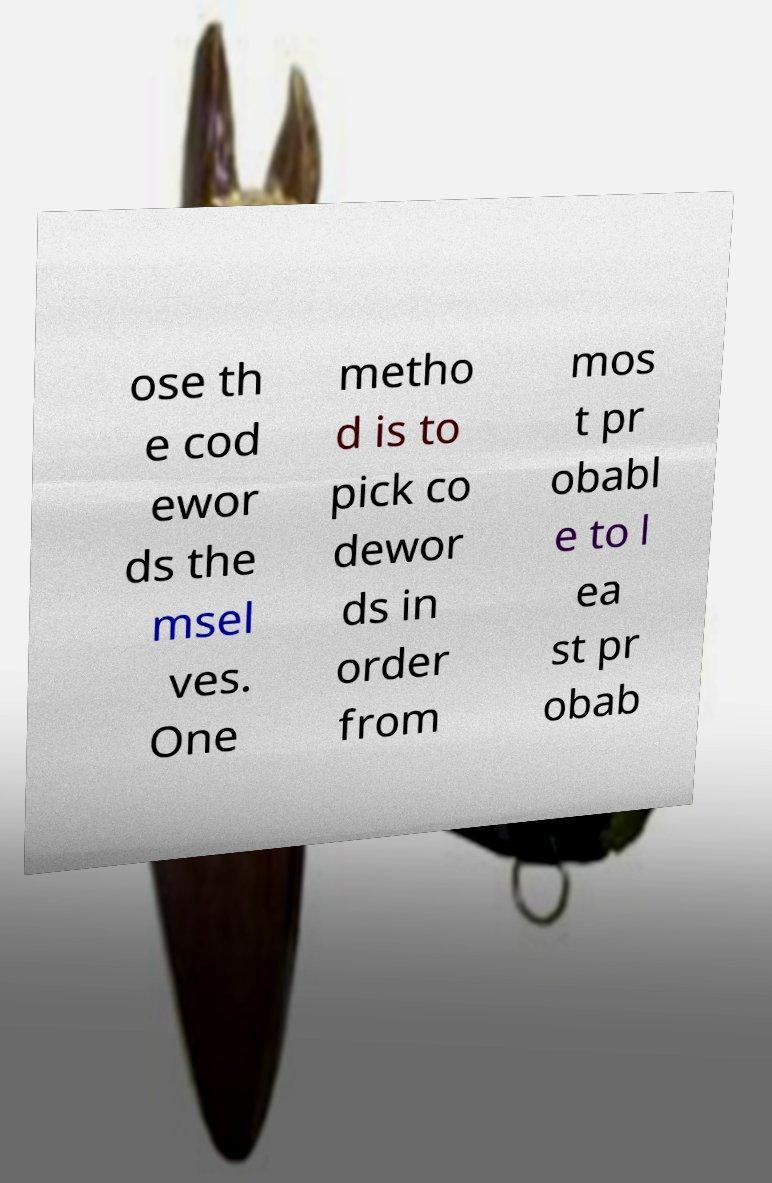Can you read and provide the text displayed in the image?This photo seems to have some interesting text. Can you extract and type it out for me? ose th e cod ewor ds the msel ves. One metho d is to pick co dewor ds in order from mos t pr obabl e to l ea st pr obab 